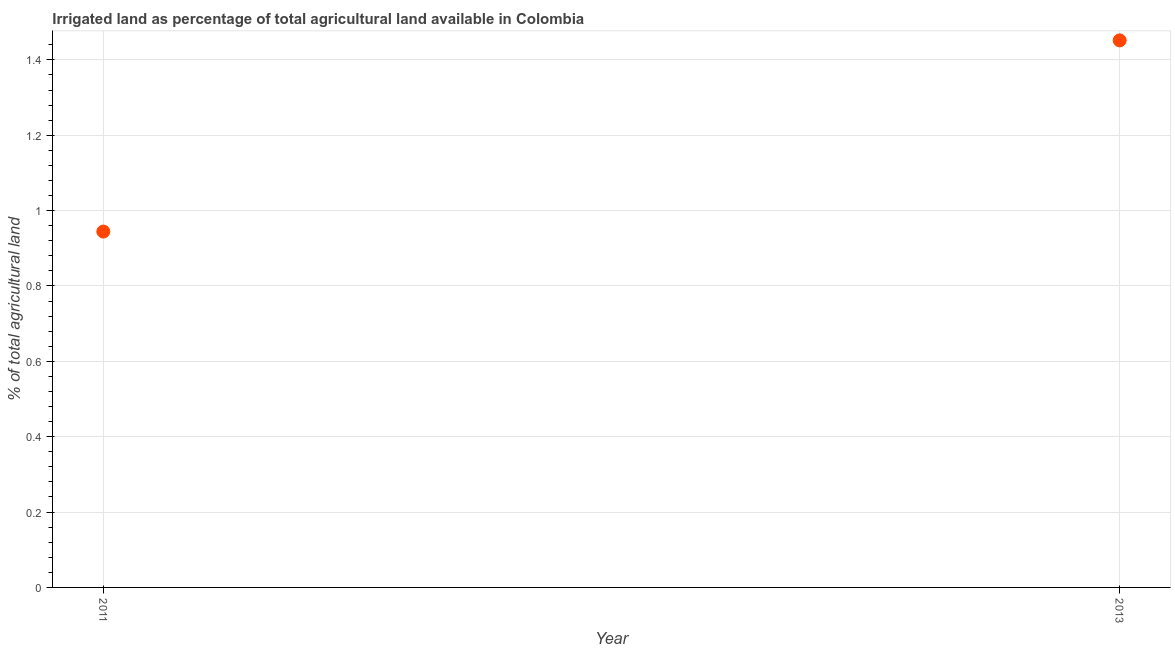What is the percentage of agricultural irrigated land in 2013?
Give a very brief answer. 1.45. Across all years, what is the maximum percentage of agricultural irrigated land?
Give a very brief answer. 1.45. Across all years, what is the minimum percentage of agricultural irrigated land?
Offer a very short reply. 0.94. In which year was the percentage of agricultural irrigated land minimum?
Ensure brevity in your answer.  2011. What is the sum of the percentage of agricultural irrigated land?
Your answer should be compact. 2.4. What is the difference between the percentage of agricultural irrigated land in 2011 and 2013?
Offer a terse response. -0.51. What is the average percentage of agricultural irrigated land per year?
Your answer should be compact. 1.2. What is the median percentage of agricultural irrigated land?
Keep it short and to the point. 1.2. Do a majority of the years between 2011 and 2013 (inclusive) have percentage of agricultural irrigated land greater than 0.88 %?
Your answer should be compact. Yes. What is the ratio of the percentage of agricultural irrigated land in 2011 to that in 2013?
Make the answer very short. 0.65. Is the percentage of agricultural irrigated land in 2011 less than that in 2013?
Your response must be concise. Yes. In how many years, is the percentage of agricultural irrigated land greater than the average percentage of agricultural irrigated land taken over all years?
Your answer should be compact. 1. Does the percentage of agricultural irrigated land monotonically increase over the years?
Provide a succinct answer. Yes. Are the values on the major ticks of Y-axis written in scientific E-notation?
Offer a terse response. No. What is the title of the graph?
Provide a succinct answer. Irrigated land as percentage of total agricultural land available in Colombia. What is the label or title of the Y-axis?
Give a very brief answer. % of total agricultural land. What is the % of total agricultural land in 2011?
Make the answer very short. 0.94. What is the % of total agricultural land in 2013?
Give a very brief answer. 1.45. What is the difference between the % of total agricultural land in 2011 and 2013?
Your response must be concise. -0.51. What is the ratio of the % of total agricultural land in 2011 to that in 2013?
Offer a terse response. 0.65. 